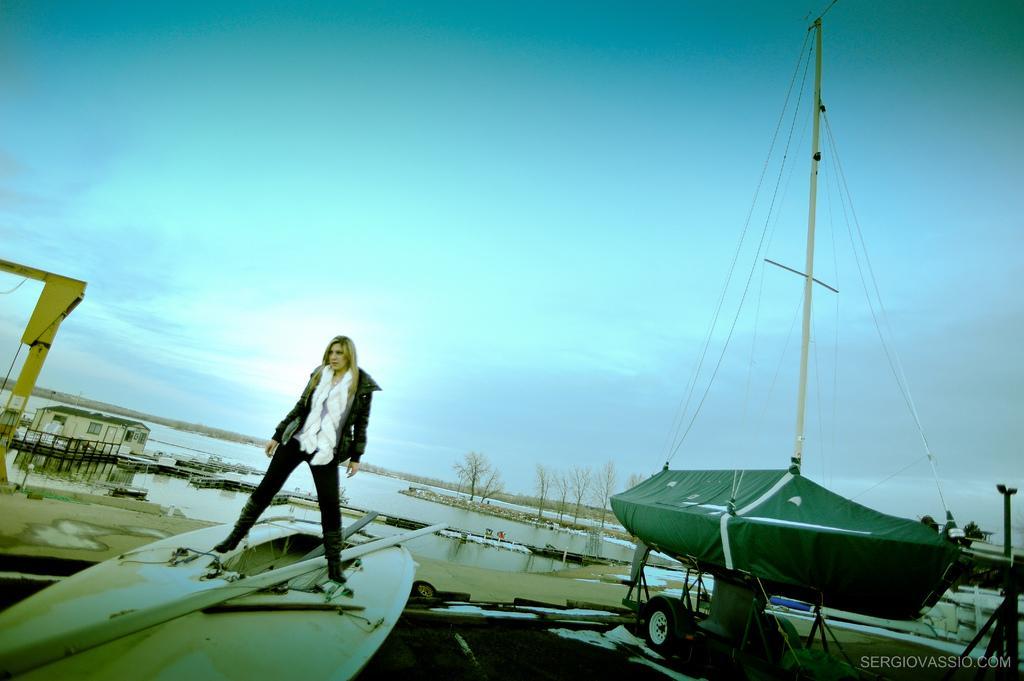Can you describe this image briefly? At the bottom of the image we can see a vehicle and a person is standing on a boat and wearing a jacket. In the background of the image we can see the water, trees, house, railing, boats, crane, poles, ropes. At the top of the image we can see the clouds in the sky. In the bottom right corner we can see the text. 